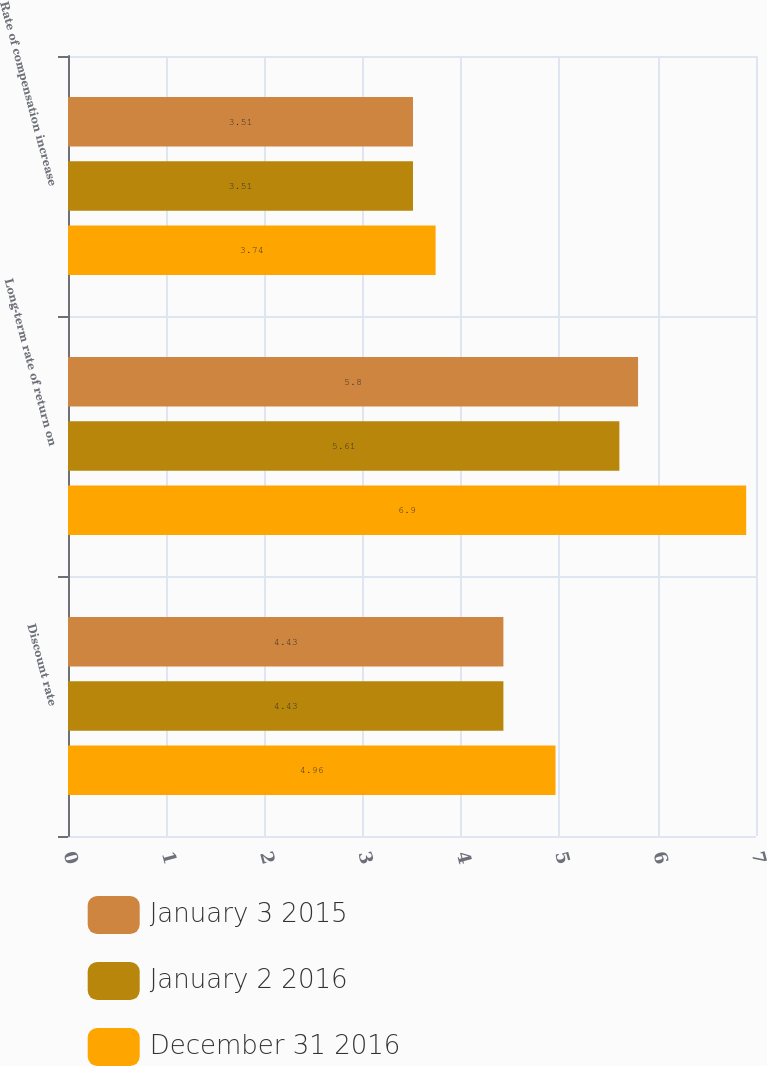Convert chart. <chart><loc_0><loc_0><loc_500><loc_500><stacked_bar_chart><ecel><fcel>Discount rate<fcel>Long-term rate of return on<fcel>Rate of compensation increase<nl><fcel>January 3 2015<fcel>4.43<fcel>5.8<fcel>3.51<nl><fcel>January 2 2016<fcel>4.43<fcel>5.61<fcel>3.51<nl><fcel>December 31 2016<fcel>4.96<fcel>6.9<fcel>3.74<nl></chart> 